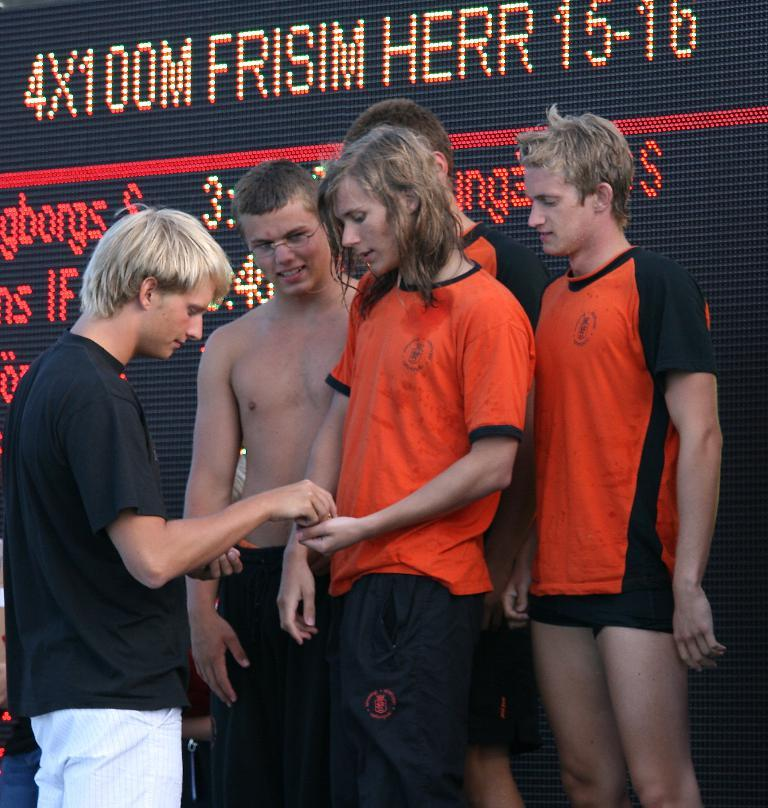How many people are in the image? There is a group of persons standing in the image, but the exact number cannot be determined without more information. What can be seen in the background of the image? There is a board in the background of the image. What is displayed on the board? There are text and numbers displayed on the board. What type of leaf is visible on the board in the image? There is no leaf visible on the board in the image; it only displays text and numbers. Are there any bushes surrounding the group of persons in the image? The facts provided do not mention any bushes or vegetation surrounding the group of persons, so we cannot determine their presence from the image. 